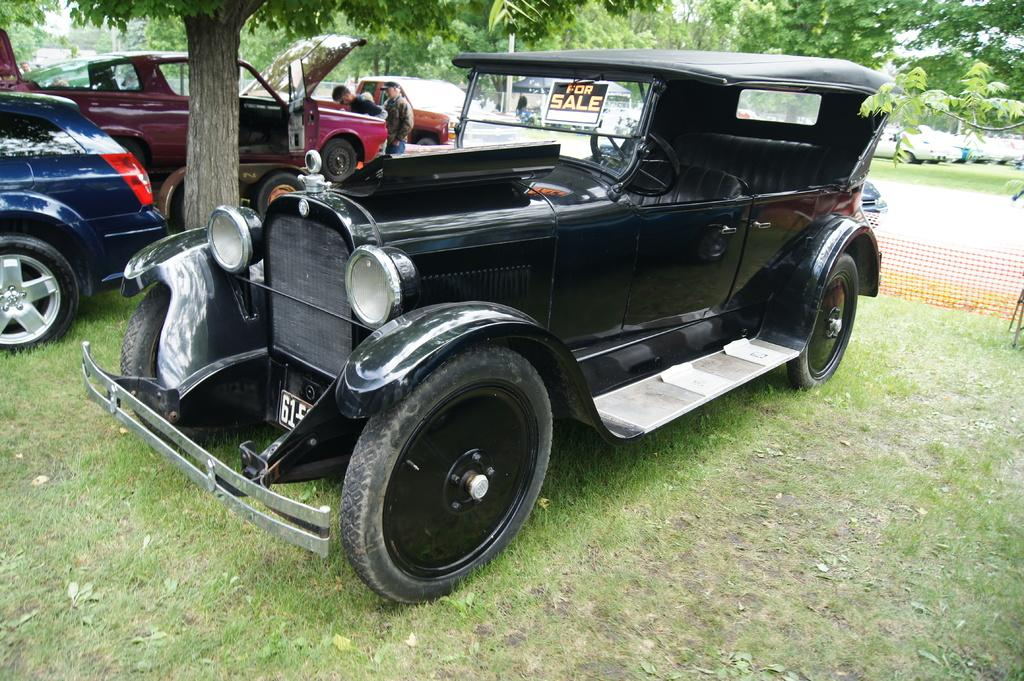What can be seen in the front of the image? In the front of the image, there are vehicles, a tree, people, a board, and grass. What is the land covered with in the image? The land is covered with grass in the image. What can be seen in the background of the image? In the background of the image, there is a mesh, vehicles, a pole, and trees. How many plants are folded in the image? There are no plants present in the image, and therefore none can be folded. What type of angle is depicted in the image? The image does not depict any angles; it shows a scene with vehicles, trees, people, and other objects. 